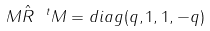Convert formula to latex. <formula><loc_0><loc_0><loc_500><loc_500>M { \hat { R } } \ ^ { t } M = d i a g ( q , 1 , 1 , - q )</formula> 